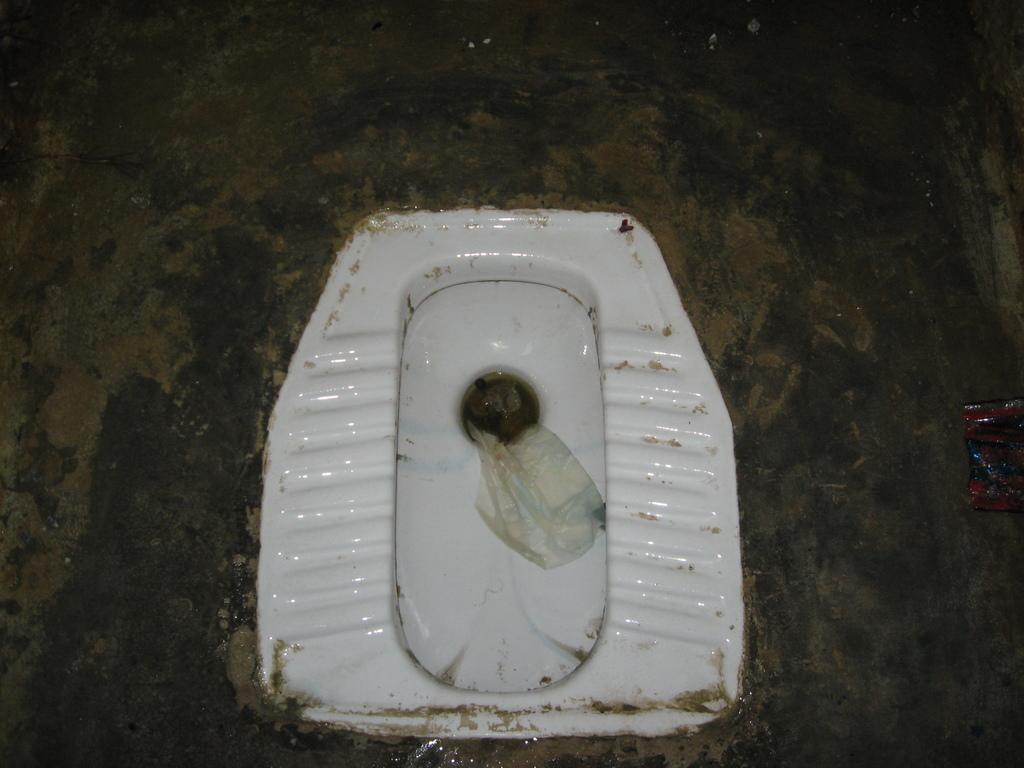What is the main object in the image? There is a toilet seat in the image. What is located near the toilet seat? There is tissue in the image. What can be seen in the background of the image? The surroundings of a toilet are visible in the image. What type of surface is visible in the image? There is a surface visible in the image. What is on the right side of the image? There is a cover on the right side of the image. What type of record is being played in the image? There is no record or music player present in the image; it features a toilet seat and related items. What type of dinner is being served in the image? There is no dinner or food present in the image; it features a toilet seat and related items. 